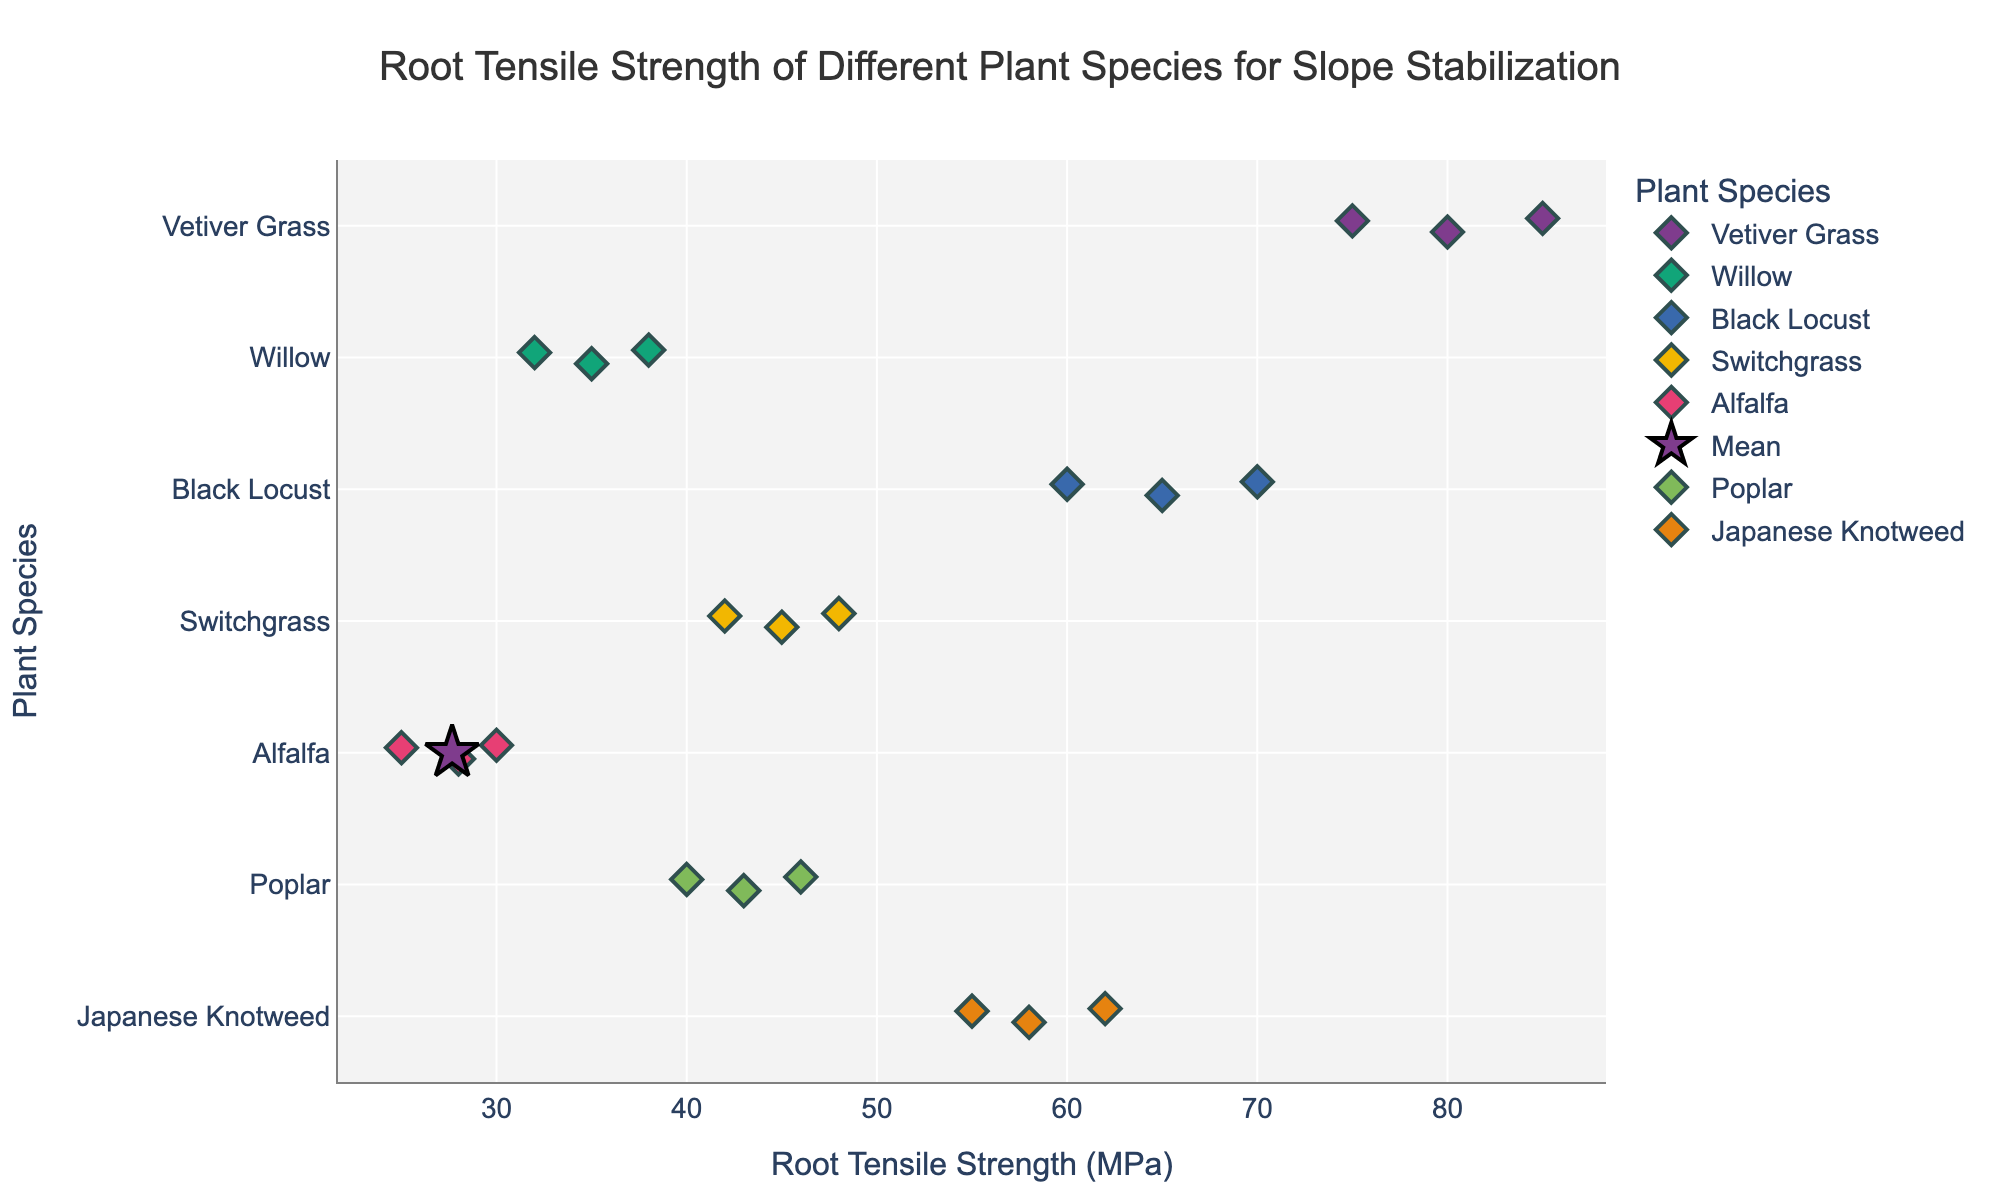What's the title of the figure? The title is located at the top of the figure. It reads "Root Tensile Strength of Different Plant Species for Slope Stabilization."
Answer: Root Tensile Strength of Different Plant Species for Slope Stabilization Which species has the highest root tensile strength? By inspecting the x-axis values, Vetiver Grass has the highest root tensile strength at 85 MPa, which is higher than the other species.
Answer: Vetiver Grass How many data points does Black Locust have? Counting the diamond markers for Black Locust on the figure reveals that Black Locust has 3 data points.
Answer: 3 Which species has the lowest average root tensile strength? By considering the mean points (stars) for each species, Alfalfa's star is placed at the lowest x-axis value.
Answer: Alfalfa What is the median root tensile strength of Poplar? There are three data points for Poplar at 40, 43, and 46 MPa. The median value is the middle one when they are ordered, which is 43 MPa.
Answer: 43 Are there any species with overlapping root tensile strength ranges? If so, which ones? By comparing the plot, Switchgrass (42-48 MPa) and Poplar (40-46 MPa) have overlapping strength values.
Answer: Switchgrass and Poplar What is the difference between the average root tensile strength of Willow and Japanese Knotweed? The average strength for Willow is (32 + 35 + 38)/3 = 35 MPa, and for Japanese Knotweed is (55 + 58 + 62)/3 = 58.33 MPa. The difference is 58.33 - 35 = 23.33 MPa.
Answer: 23.33 MPa Which species has the highest range in root tensile strength? Vetiver Grass ranges from 75 to 85 MPa, which gives a range of 10 MPa. No other species surpasses this range.
Answer: Vetiver Grass Do the stars representing the mean values have a different marker color compared to the diamond markers? Yes, the stars are in a different color from the diamonds to distinguish average values from individual data points.
Answer: Yes 